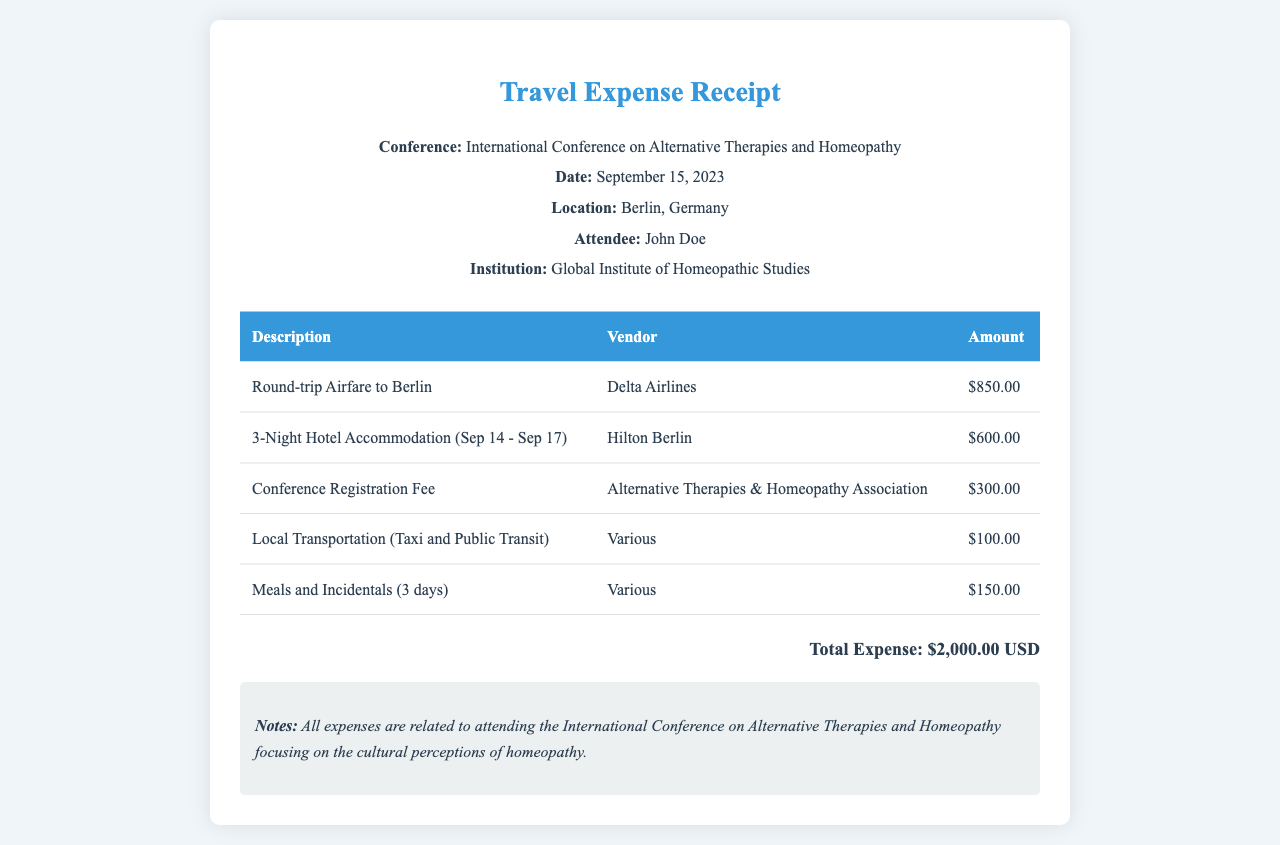What is the attendee's name? The attendee's name is listed in the document under the attendee section.
Answer: John Doe What was the location of the conference? The location of the conference is provided in the header section of the document.
Answer: Berlin, Germany What is the total expense recorded in the receipt? The total expense is calculated as the sum of all expenses listed in the document.
Answer: $2,000.00 USD How many nights of hotel accommodation are included? The duration of hotel accommodation is specified in the description of that expense.
Answer: 3-Night What is the amount for Meals and Incidentals? The amount for Meals and Incidentals is mentioned in the table under the relevant description.
Answer: $150.00 What vendor provided the airfare? The vendor for the round-trip airfare is mentioned in the table associated with that expense.
Answer: Delta Airlines What is the conference registration fee? The registration fee is explicitly stated in the table of expenses.
Answer: $300.00 What dates were the hotel accommodations for? The dates are included in the description of the hotel accommodation in the expense table.
Answer: Sep 14 - Sep 17 What type of notes are included in the receipt? The notes section provides details about the relevance of the expenses to the conference theme.
Answer: Cultural perceptions of homeopathy 